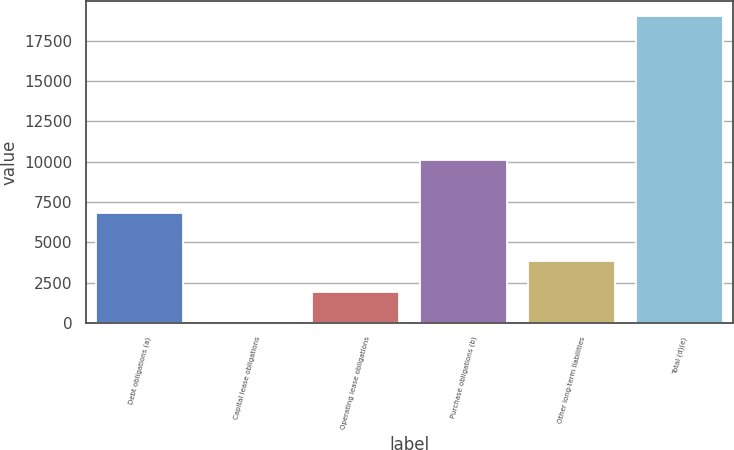Convert chart. <chart><loc_0><loc_0><loc_500><loc_500><bar_chart><fcel>Debt obligations (a)<fcel>Capital lease obligations<fcel>Operating lease obligations<fcel>Purchase obligations (b)<fcel>Other long-term liabilities<fcel>Total (d)(e)<nl><fcel>6842<fcel>47<fcel>1941.9<fcel>10080<fcel>3836.8<fcel>18996<nl></chart> 